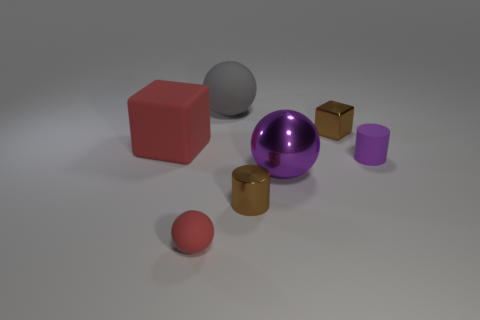Does the small matte cylinder have the same color as the large shiny ball?
Provide a short and direct response. Yes. There is a thing that is the same color as the matte cube; what is it made of?
Keep it short and to the point. Rubber. Does the large thing behind the small metal cube have the same shape as the tiny matte object in front of the tiny brown cylinder?
Keep it short and to the point. Yes. Is there anything else that has the same color as the shiny block?
Provide a succinct answer. Yes. What shape is the big rubber object to the left of the large rubber thing that is right of the red object that is behind the small red object?
Provide a short and direct response. Cube. What is the thing that is behind the large red thing and on the right side of the purple sphere made of?
Keep it short and to the point. Metal. How many other things are the same size as the purple metallic object?
Offer a very short reply. 2. What number of shiny things are small red balls or small blue things?
Offer a very short reply. 0. What material is the tiny brown cylinder?
Provide a short and direct response. Metal. There is a large metallic object; what number of big gray spheres are behind it?
Your response must be concise. 1. 